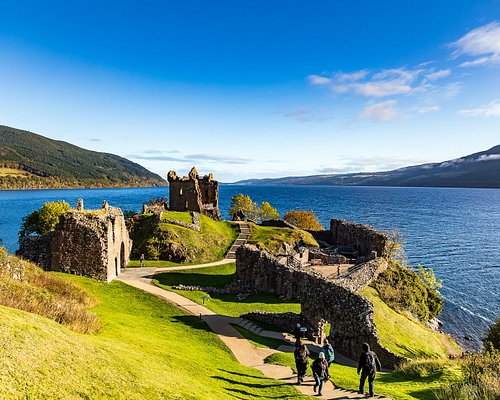Can you tell me more about the history of Urquhart Castle? Certainly! Urquhart Castle has a rich and tumultuous history that dates back to the 13th century. It played a strategic role in the Scottish Wars of Independence, frequently changing hands between the English and the Scots. The castle witnessed numerous battles and sieges, including attacks by the infamous William Wallace. In the 17th century, it was partially destroyed to prevent it from being used by opposing forces. Today, it stands as a symbol of Scotland's resilient spirit and is one of the country's most visited historic sites, offering not only a glimpse into the past but also spectacular views of Loch Ness. 